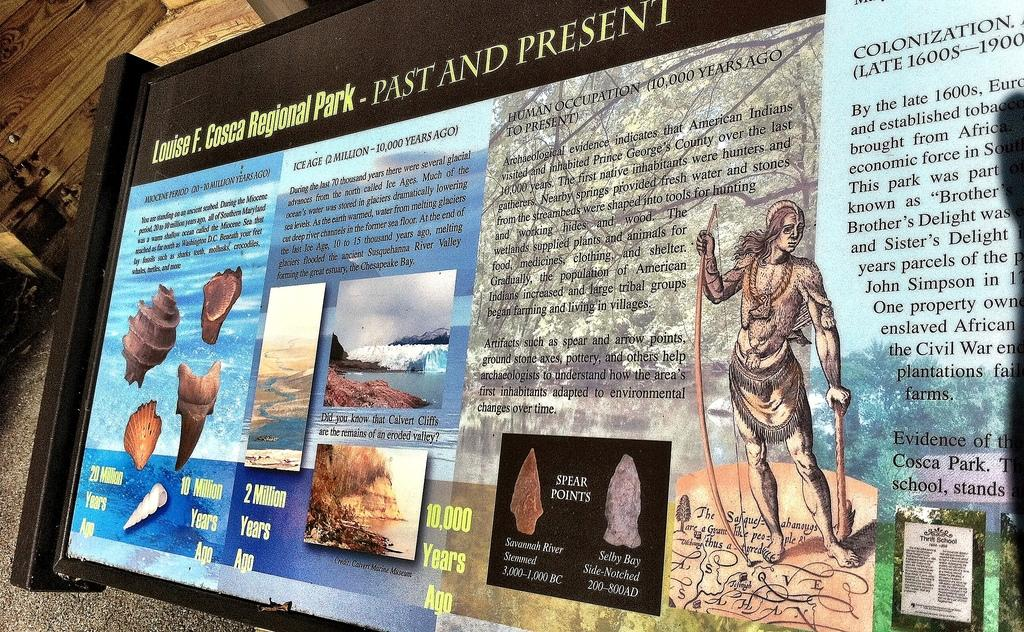<image>
Relay a brief, clear account of the picture shown. Louise F. Cosca Regional Park Past and Present information 